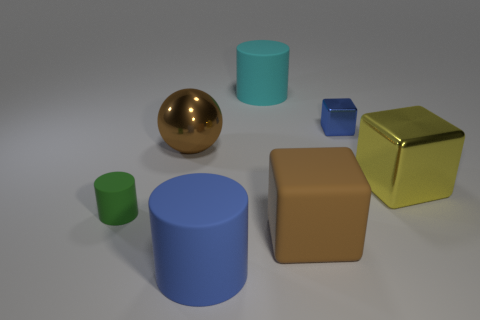Add 1 green matte things. How many objects exist? 8 Subtract all cylinders. How many objects are left? 4 Subtract 1 blue cubes. How many objects are left? 6 Subtract all tiny brown spheres. Subtract all big blue rubber objects. How many objects are left? 6 Add 6 big yellow blocks. How many big yellow blocks are left? 7 Add 4 brown objects. How many brown objects exist? 6 